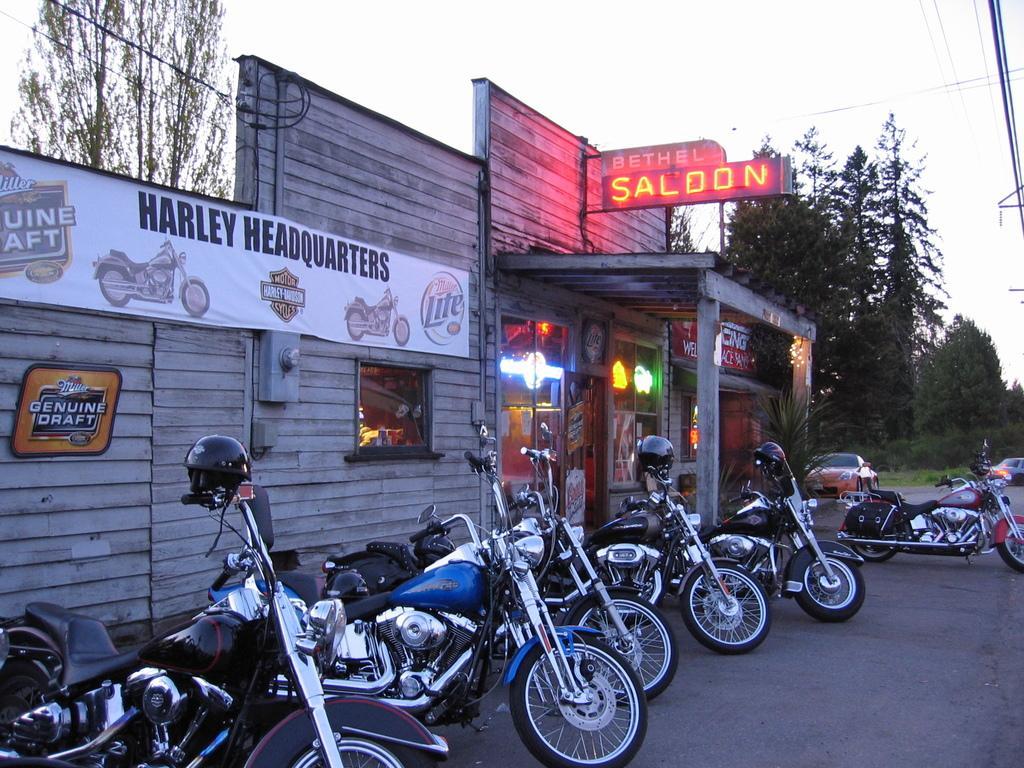Describe this image in one or two sentences. In this image we can see a store. There is an advertising board in the image. There are few posters in the image. There are many trees and plants in the image. There are few cables in the image. We can see the sky in the image. 